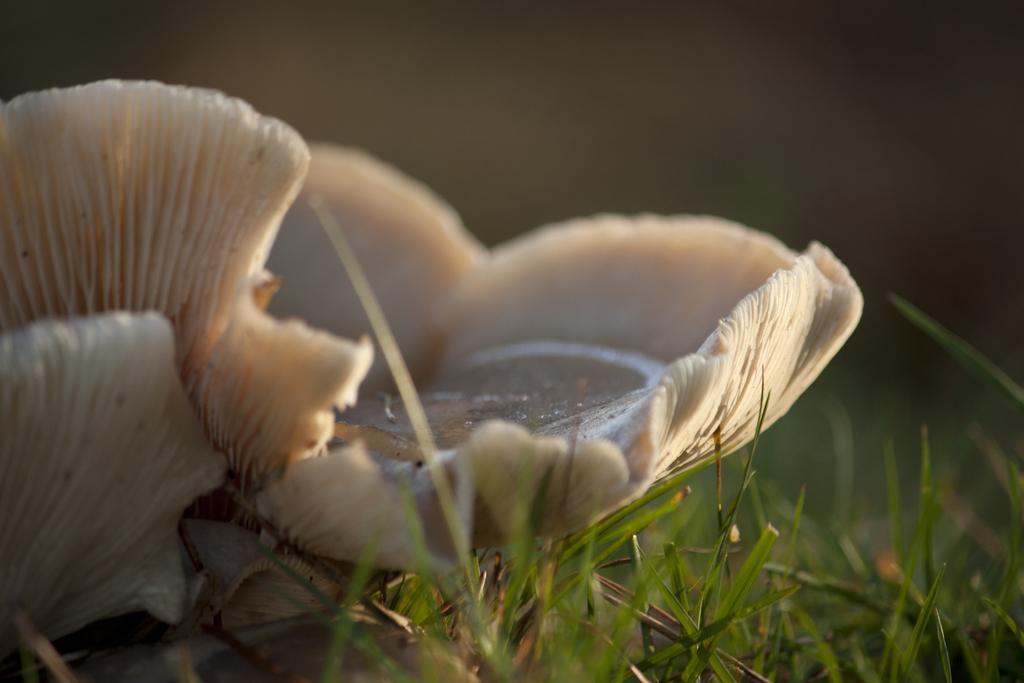Describe this image in one or two sentences. In this image I see a white color thing over here and I see the green grass and it is blurred in the background. 